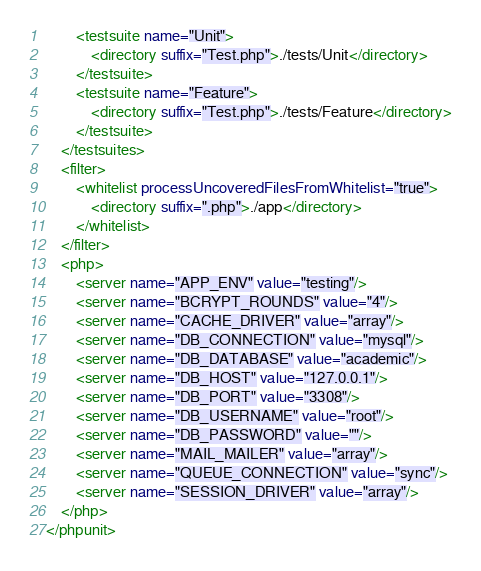Convert code to text. <code><loc_0><loc_0><loc_500><loc_500><_XML_>        <testsuite name="Unit">
            <directory suffix="Test.php">./tests/Unit</directory>
        </testsuite>
        <testsuite name="Feature">
            <directory suffix="Test.php">./tests/Feature</directory>
        </testsuite>
    </testsuites>
    <filter>
        <whitelist processUncoveredFilesFromWhitelist="true">
            <directory suffix=".php">./app</directory>
        </whitelist>
    </filter>
    <php>
        <server name="APP_ENV" value="testing"/>
        <server name="BCRYPT_ROUNDS" value="4"/>
        <server name="CACHE_DRIVER" value="array"/>
        <server name="DB_CONNECTION" value="mysql"/>
        <server name="DB_DATABASE" value="academic"/>
        <server name="DB_HOST" value="127.0.0.1"/>
        <server name="DB_PORT" value="3308"/>
        <server name="DB_USERNAME" value="root"/>
        <server name="DB_PASSWORD" value=""/>
        <server name="MAIL_MAILER" value="array"/>
        <server name="QUEUE_CONNECTION" value="sync"/>
        <server name="SESSION_DRIVER" value="array"/>
    </php>
</phpunit>
</code> 